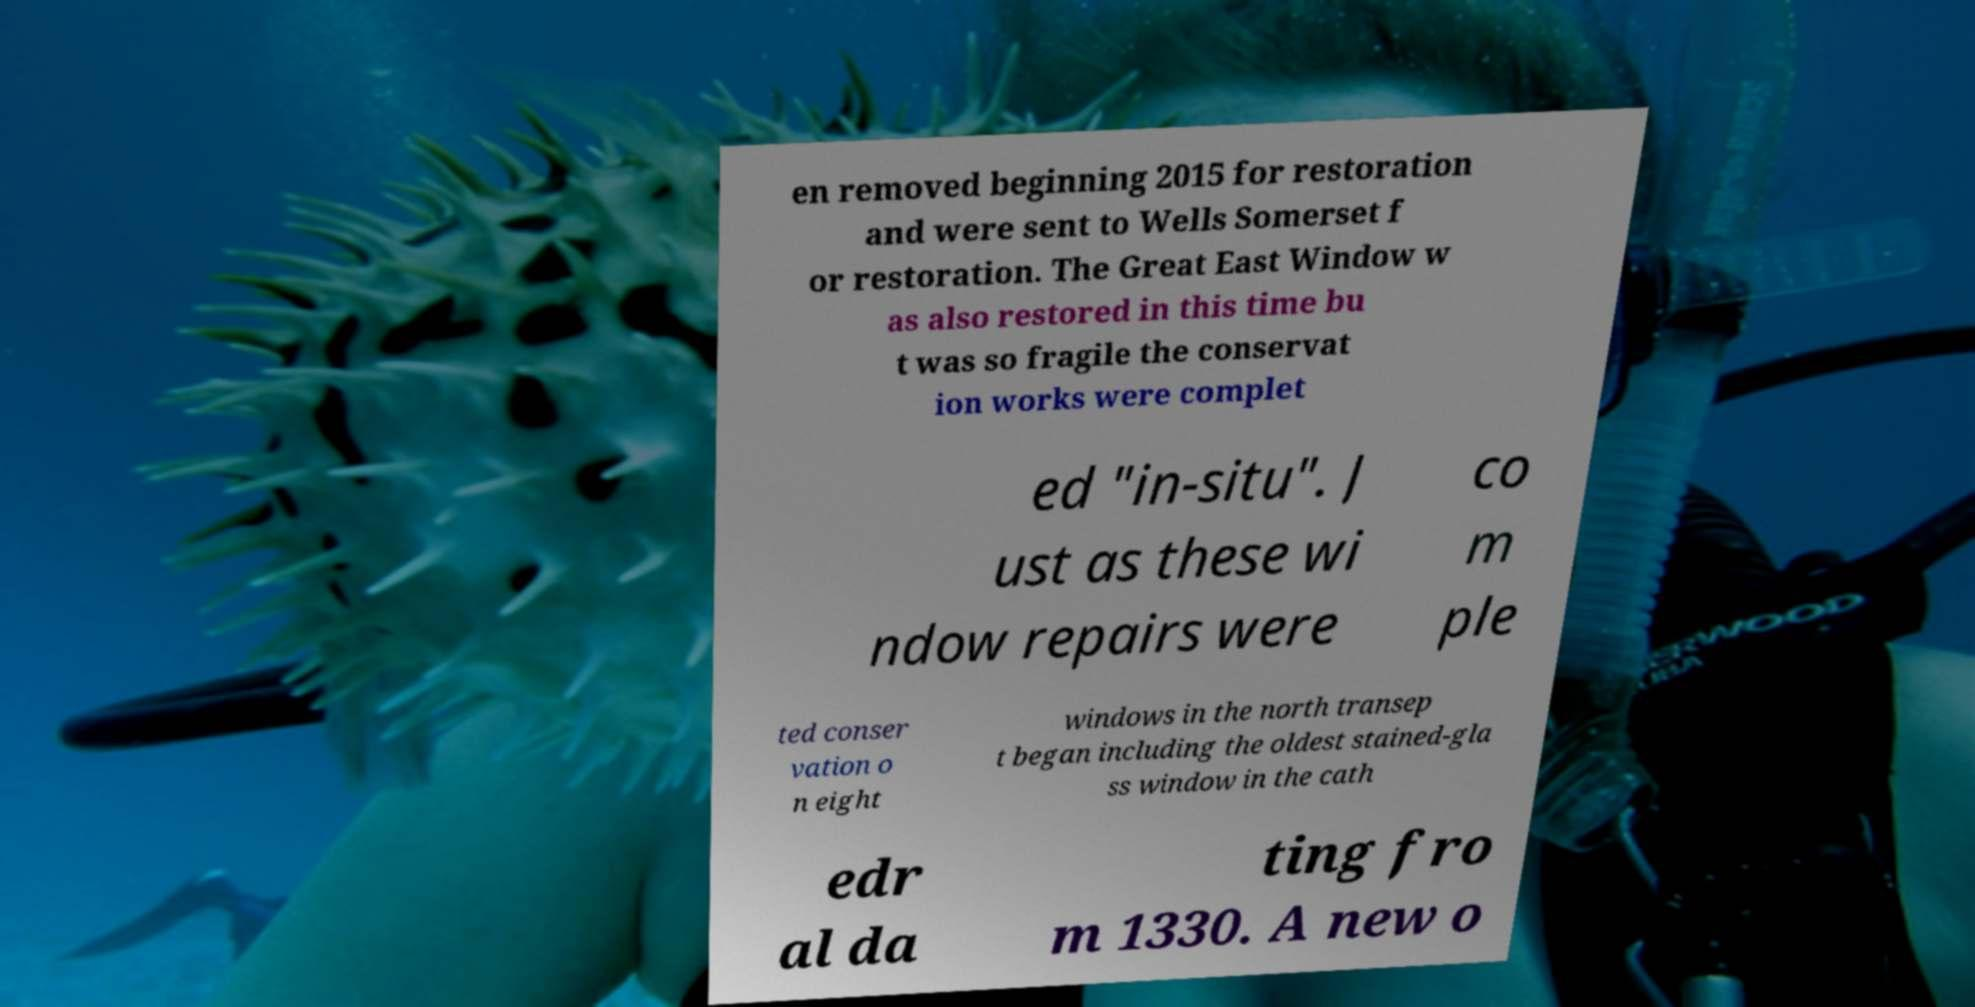Please identify and transcribe the text found in this image. en removed beginning 2015 for restoration and were sent to Wells Somerset f or restoration. The Great East Window w as also restored in this time bu t was so fragile the conservat ion works were complet ed "in-situ". J ust as these wi ndow repairs were co m ple ted conser vation o n eight windows in the north transep t began including the oldest stained-gla ss window in the cath edr al da ting fro m 1330. A new o 